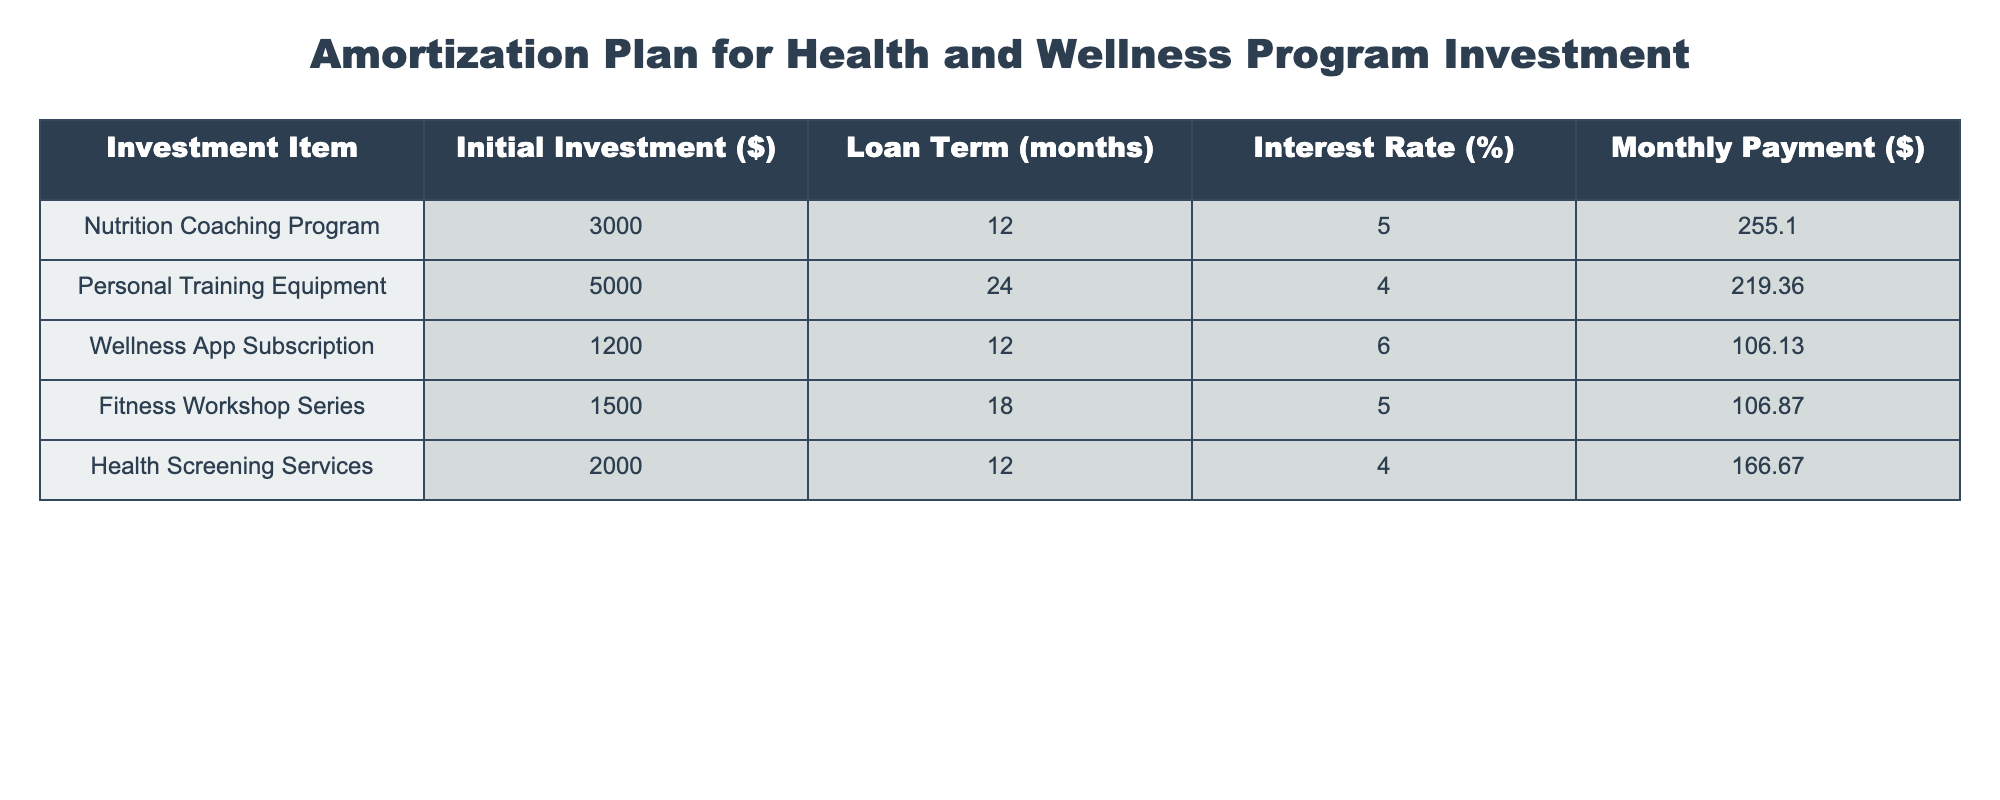What is the initial investment for the Nutrition Coaching Program? The initial investment value is stated directly in the table under the "Initial Investment ($)" column for the Nutrition Coaching Program. The corresponding value is 3000.
Answer: 3000 What is the monthly payment for the Personal Training Equipment? The monthly payment value is listed in the table under the "Monthly Payment ($)" column for Personal Training Equipment. The value given is 219.36.
Answer: 219.36 Which investment item has the highest interest rate? By comparing the "Interest Rate (%)" column values across all investment items, it can be observed that the Wellness App Subscription has the highest interest rate of 6%.
Answer: Wellness App Subscription What is the total initial investment for all listed items? To find the total initial investment, sum the initial investments of each item: 3000 + 5000 + 1200 + 1500 + 2000 = 12700.
Answer: 12700 Is the monthly payment for the Fitness Workshop Series less than 110? The monthly payment for the Fitness Workshop Series is 106.87, which is indeed less than 110.
Answer: Yes What is the average loan term in months for all investment items? To calculate the average loan term, sum all loan terms: 12 + 24 + 12 + 18 + 12 = 78. There are 5 items, so the average loan term is 78/5 = 15.6 months.
Answer: 15.6 Which investment item has the lowest monthly payment, and what is that payment? Checking the "Monthly Payment ($)" column reveals that the Wellness App Subscription has the lowest payment at 106.13.
Answer: Wellness App Subscription, 106.13 What is the difference in monthly payments between the Nutrition Coaching Program and the Health Screening Services? First, identify the monthly payments: Nutrition Coaching Program is 255.10, Health Screening Services is 166.67. The difference is 255.10 - 166.67 = 88.43.
Answer: 88.43 Is the total initial investment for the Nutrition Coaching Program and Health Screening Services greater than 5000? The initial investments for both are 3000 (Nutrition Coaching Program) and 2000 (Health Screening Services), summing to 3000 + 2000 = 5000, which is not greater than 5000.
Answer: No 